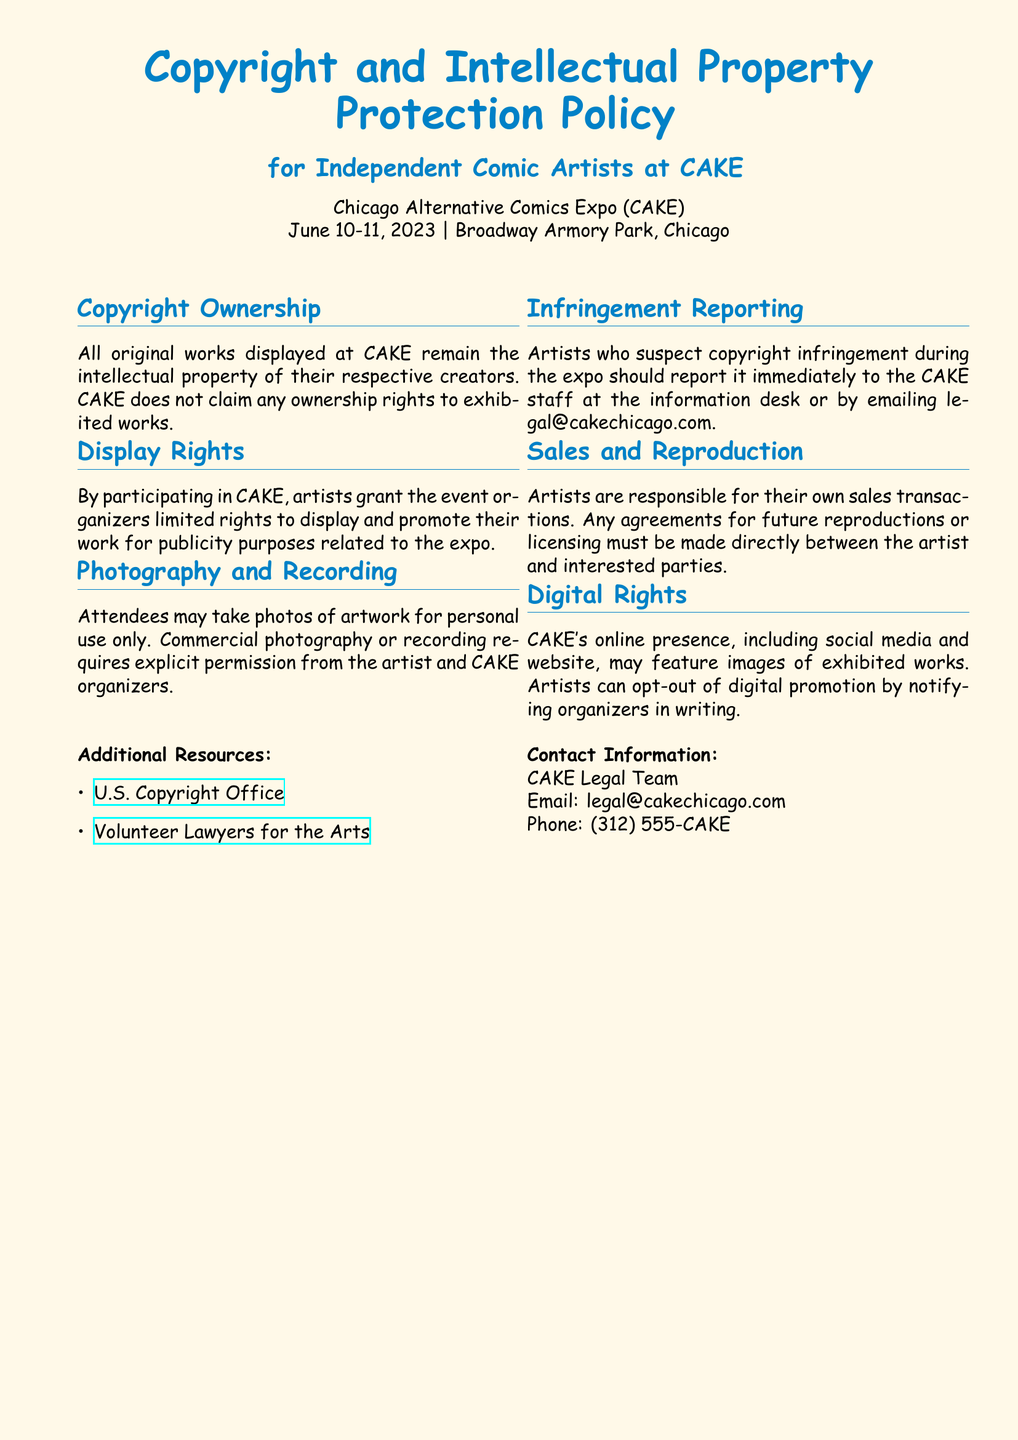What are the dates of CAKE? The dates of the event are listed at the top of the document as June 10-11, 2023.
Answer: June 10-11, 2023 Who owns the copyright of the displayed works? The document states that all original works displayed at CAKE remain the intellectual property of their respective creators.
Answer: Their respective creators What should artists do if they suspect copyright infringement? The document indicates that artists should report any suspected infringement to CAKE staff or via email to the provided address.
Answer: Report it immediately Who is responsible for sales transactions at CAKE? According to the document, artists are responsible for their own sales transactions.
Answer: Artists What can artists do if they want to opt-out of digital promotion? The document mentions that artists can opt-out by notifying organizers in writing.
Answer: Notify organizers in writing 